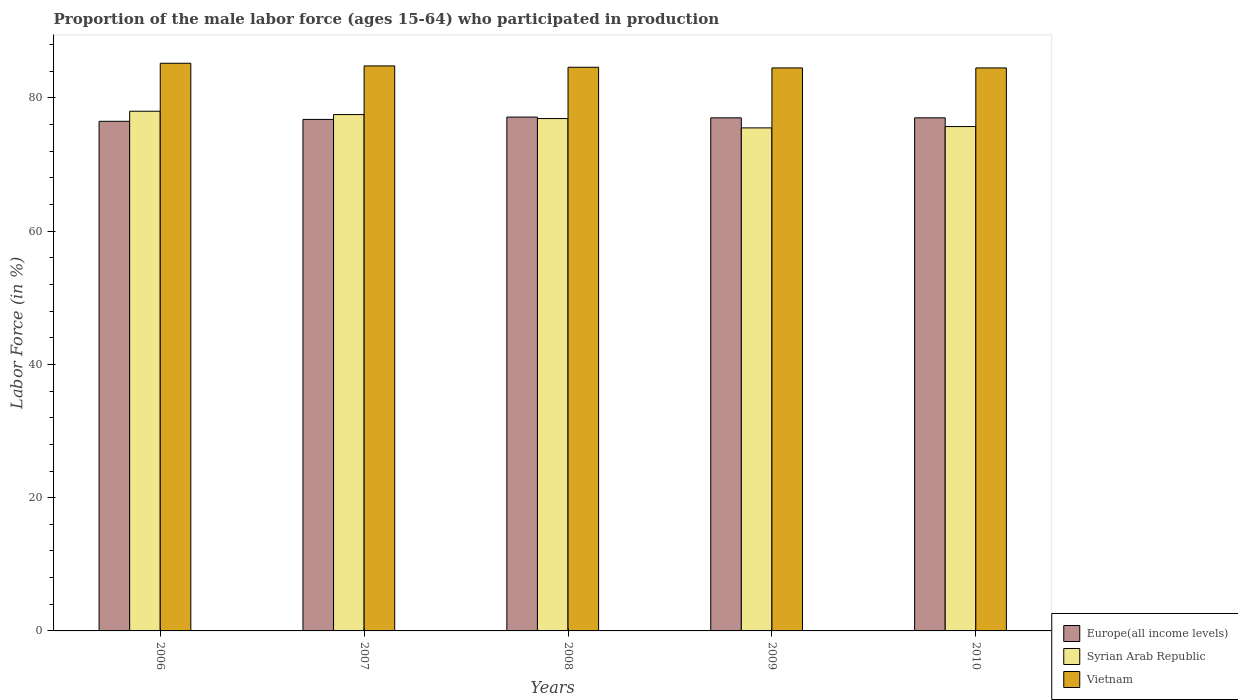How many different coloured bars are there?
Ensure brevity in your answer.  3. How many groups of bars are there?
Give a very brief answer. 5. Are the number of bars per tick equal to the number of legend labels?
Offer a terse response. Yes. Are the number of bars on each tick of the X-axis equal?
Your answer should be very brief. Yes. How many bars are there on the 4th tick from the left?
Give a very brief answer. 3. How many bars are there on the 1st tick from the right?
Provide a short and direct response. 3. What is the label of the 2nd group of bars from the left?
Keep it short and to the point. 2007. In how many cases, is the number of bars for a given year not equal to the number of legend labels?
Keep it short and to the point. 0. What is the proportion of the male labor force who participated in production in Europe(all income levels) in 2007?
Ensure brevity in your answer.  76.77. Across all years, what is the maximum proportion of the male labor force who participated in production in Syrian Arab Republic?
Make the answer very short. 78. Across all years, what is the minimum proportion of the male labor force who participated in production in Europe(all income levels)?
Your answer should be compact. 76.49. In which year was the proportion of the male labor force who participated in production in Syrian Arab Republic minimum?
Your response must be concise. 2009. What is the total proportion of the male labor force who participated in production in Vietnam in the graph?
Offer a very short reply. 423.6. What is the difference between the proportion of the male labor force who participated in production in Europe(all income levels) in 2006 and that in 2009?
Offer a terse response. -0.52. What is the difference between the proportion of the male labor force who participated in production in Europe(all income levels) in 2010 and the proportion of the male labor force who participated in production in Vietnam in 2009?
Provide a short and direct response. -7.49. What is the average proportion of the male labor force who participated in production in Vietnam per year?
Offer a terse response. 84.72. What is the ratio of the proportion of the male labor force who participated in production in Vietnam in 2008 to that in 2010?
Offer a terse response. 1. Is the proportion of the male labor force who participated in production in Syrian Arab Republic in 2008 less than that in 2009?
Keep it short and to the point. No. Is the difference between the proportion of the male labor force who participated in production in Vietnam in 2009 and 2010 greater than the difference between the proportion of the male labor force who participated in production in Syrian Arab Republic in 2009 and 2010?
Your answer should be very brief. Yes. What is the difference between the highest and the second highest proportion of the male labor force who participated in production in Vietnam?
Your answer should be compact. 0.4. What is the difference between the highest and the lowest proportion of the male labor force who participated in production in Syrian Arab Republic?
Your response must be concise. 2.5. What does the 3rd bar from the left in 2007 represents?
Ensure brevity in your answer.  Vietnam. What does the 3rd bar from the right in 2009 represents?
Keep it short and to the point. Europe(all income levels). Is it the case that in every year, the sum of the proportion of the male labor force who participated in production in Europe(all income levels) and proportion of the male labor force who participated in production in Vietnam is greater than the proportion of the male labor force who participated in production in Syrian Arab Republic?
Ensure brevity in your answer.  Yes. How many bars are there?
Your answer should be compact. 15. How many years are there in the graph?
Make the answer very short. 5. Are the values on the major ticks of Y-axis written in scientific E-notation?
Your answer should be very brief. No. Does the graph contain grids?
Ensure brevity in your answer.  No. What is the title of the graph?
Provide a short and direct response. Proportion of the male labor force (ages 15-64) who participated in production. Does "Lithuania" appear as one of the legend labels in the graph?
Your response must be concise. No. What is the label or title of the X-axis?
Your answer should be compact. Years. What is the label or title of the Y-axis?
Offer a terse response. Labor Force (in %). What is the Labor Force (in %) in Europe(all income levels) in 2006?
Offer a terse response. 76.49. What is the Labor Force (in %) in Vietnam in 2006?
Give a very brief answer. 85.2. What is the Labor Force (in %) of Europe(all income levels) in 2007?
Provide a succinct answer. 76.77. What is the Labor Force (in %) of Syrian Arab Republic in 2007?
Offer a very short reply. 77.5. What is the Labor Force (in %) in Vietnam in 2007?
Ensure brevity in your answer.  84.8. What is the Labor Force (in %) of Europe(all income levels) in 2008?
Your answer should be compact. 77.12. What is the Labor Force (in %) of Syrian Arab Republic in 2008?
Provide a succinct answer. 76.9. What is the Labor Force (in %) in Vietnam in 2008?
Offer a very short reply. 84.6. What is the Labor Force (in %) of Europe(all income levels) in 2009?
Ensure brevity in your answer.  77.01. What is the Labor Force (in %) in Syrian Arab Republic in 2009?
Offer a terse response. 75.5. What is the Labor Force (in %) in Vietnam in 2009?
Provide a short and direct response. 84.5. What is the Labor Force (in %) in Europe(all income levels) in 2010?
Make the answer very short. 77.01. What is the Labor Force (in %) in Syrian Arab Republic in 2010?
Make the answer very short. 75.7. What is the Labor Force (in %) in Vietnam in 2010?
Your answer should be very brief. 84.5. Across all years, what is the maximum Labor Force (in %) of Europe(all income levels)?
Your answer should be very brief. 77.12. Across all years, what is the maximum Labor Force (in %) of Vietnam?
Your response must be concise. 85.2. Across all years, what is the minimum Labor Force (in %) of Europe(all income levels)?
Make the answer very short. 76.49. Across all years, what is the minimum Labor Force (in %) in Syrian Arab Republic?
Your response must be concise. 75.5. Across all years, what is the minimum Labor Force (in %) of Vietnam?
Your answer should be compact. 84.5. What is the total Labor Force (in %) in Europe(all income levels) in the graph?
Your response must be concise. 384.4. What is the total Labor Force (in %) in Syrian Arab Republic in the graph?
Offer a very short reply. 383.6. What is the total Labor Force (in %) of Vietnam in the graph?
Provide a succinct answer. 423.6. What is the difference between the Labor Force (in %) of Europe(all income levels) in 2006 and that in 2007?
Offer a very short reply. -0.29. What is the difference between the Labor Force (in %) in Europe(all income levels) in 2006 and that in 2008?
Make the answer very short. -0.63. What is the difference between the Labor Force (in %) in Vietnam in 2006 and that in 2008?
Give a very brief answer. 0.6. What is the difference between the Labor Force (in %) in Europe(all income levels) in 2006 and that in 2009?
Your response must be concise. -0.52. What is the difference between the Labor Force (in %) in Syrian Arab Republic in 2006 and that in 2009?
Offer a very short reply. 2.5. What is the difference between the Labor Force (in %) in Vietnam in 2006 and that in 2009?
Your answer should be compact. 0.7. What is the difference between the Labor Force (in %) in Europe(all income levels) in 2006 and that in 2010?
Offer a terse response. -0.52. What is the difference between the Labor Force (in %) of Syrian Arab Republic in 2006 and that in 2010?
Your response must be concise. 2.3. What is the difference between the Labor Force (in %) in Vietnam in 2006 and that in 2010?
Offer a very short reply. 0.7. What is the difference between the Labor Force (in %) of Europe(all income levels) in 2007 and that in 2008?
Make the answer very short. -0.35. What is the difference between the Labor Force (in %) in Syrian Arab Republic in 2007 and that in 2008?
Give a very brief answer. 0.6. What is the difference between the Labor Force (in %) of Vietnam in 2007 and that in 2008?
Make the answer very short. 0.2. What is the difference between the Labor Force (in %) of Europe(all income levels) in 2007 and that in 2009?
Your answer should be very brief. -0.24. What is the difference between the Labor Force (in %) in Vietnam in 2007 and that in 2009?
Your answer should be compact. 0.3. What is the difference between the Labor Force (in %) of Europe(all income levels) in 2007 and that in 2010?
Make the answer very short. -0.24. What is the difference between the Labor Force (in %) in Syrian Arab Republic in 2007 and that in 2010?
Provide a short and direct response. 1.8. What is the difference between the Labor Force (in %) of Europe(all income levels) in 2008 and that in 2009?
Give a very brief answer. 0.11. What is the difference between the Labor Force (in %) of Europe(all income levels) in 2008 and that in 2010?
Provide a succinct answer. 0.11. What is the difference between the Labor Force (in %) in Europe(all income levels) in 2009 and that in 2010?
Ensure brevity in your answer.  -0. What is the difference between the Labor Force (in %) of Vietnam in 2009 and that in 2010?
Make the answer very short. 0. What is the difference between the Labor Force (in %) in Europe(all income levels) in 2006 and the Labor Force (in %) in Syrian Arab Republic in 2007?
Provide a succinct answer. -1.01. What is the difference between the Labor Force (in %) of Europe(all income levels) in 2006 and the Labor Force (in %) of Vietnam in 2007?
Provide a short and direct response. -8.31. What is the difference between the Labor Force (in %) of Syrian Arab Republic in 2006 and the Labor Force (in %) of Vietnam in 2007?
Keep it short and to the point. -6.8. What is the difference between the Labor Force (in %) of Europe(all income levels) in 2006 and the Labor Force (in %) of Syrian Arab Republic in 2008?
Give a very brief answer. -0.41. What is the difference between the Labor Force (in %) in Europe(all income levels) in 2006 and the Labor Force (in %) in Vietnam in 2008?
Provide a succinct answer. -8.11. What is the difference between the Labor Force (in %) of Syrian Arab Republic in 2006 and the Labor Force (in %) of Vietnam in 2008?
Offer a very short reply. -6.6. What is the difference between the Labor Force (in %) in Europe(all income levels) in 2006 and the Labor Force (in %) in Syrian Arab Republic in 2009?
Provide a short and direct response. 0.99. What is the difference between the Labor Force (in %) of Europe(all income levels) in 2006 and the Labor Force (in %) of Vietnam in 2009?
Your answer should be compact. -8.01. What is the difference between the Labor Force (in %) of Syrian Arab Republic in 2006 and the Labor Force (in %) of Vietnam in 2009?
Give a very brief answer. -6.5. What is the difference between the Labor Force (in %) of Europe(all income levels) in 2006 and the Labor Force (in %) of Syrian Arab Republic in 2010?
Keep it short and to the point. 0.79. What is the difference between the Labor Force (in %) in Europe(all income levels) in 2006 and the Labor Force (in %) in Vietnam in 2010?
Your answer should be compact. -8.01. What is the difference between the Labor Force (in %) of Syrian Arab Republic in 2006 and the Labor Force (in %) of Vietnam in 2010?
Your answer should be very brief. -6.5. What is the difference between the Labor Force (in %) of Europe(all income levels) in 2007 and the Labor Force (in %) of Syrian Arab Republic in 2008?
Offer a very short reply. -0.13. What is the difference between the Labor Force (in %) in Europe(all income levels) in 2007 and the Labor Force (in %) in Vietnam in 2008?
Your response must be concise. -7.83. What is the difference between the Labor Force (in %) in Syrian Arab Republic in 2007 and the Labor Force (in %) in Vietnam in 2008?
Provide a short and direct response. -7.1. What is the difference between the Labor Force (in %) in Europe(all income levels) in 2007 and the Labor Force (in %) in Syrian Arab Republic in 2009?
Keep it short and to the point. 1.27. What is the difference between the Labor Force (in %) of Europe(all income levels) in 2007 and the Labor Force (in %) of Vietnam in 2009?
Your answer should be compact. -7.73. What is the difference between the Labor Force (in %) of Europe(all income levels) in 2007 and the Labor Force (in %) of Syrian Arab Republic in 2010?
Offer a terse response. 1.07. What is the difference between the Labor Force (in %) in Europe(all income levels) in 2007 and the Labor Force (in %) in Vietnam in 2010?
Your response must be concise. -7.73. What is the difference between the Labor Force (in %) in Syrian Arab Republic in 2007 and the Labor Force (in %) in Vietnam in 2010?
Offer a very short reply. -7. What is the difference between the Labor Force (in %) in Europe(all income levels) in 2008 and the Labor Force (in %) in Syrian Arab Republic in 2009?
Your response must be concise. 1.62. What is the difference between the Labor Force (in %) of Europe(all income levels) in 2008 and the Labor Force (in %) of Vietnam in 2009?
Your response must be concise. -7.38. What is the difference between the Labor Force (in %) of Syrian Arab Republic in 2008 and the Labor Force (in %) of Vietnam in 2009?
Keep it short and to the point. -7.6. What is the difference between the Labor Force (in %) of Europe(all income levels) in 2008 and the Labor Force (in %) of Syrian Arab Republic in 2010?
Provide a short and direct response. 1.42. What is the difference between the Labor Force (in %) in Europe(all income levels) in 2008 and the Labor Force (in %) in Vietnam in 2010?
Your answer should be compact. -7.38. What is the difference between the Labor Force (in %) of Europe(all income levels) in 2009 and the Labor Force (in %) of Syrian Arab Republic in 2010?
Your answer should be very brief. 1.31. What is the difference between the Labor Force (in %) of Europe(all income levels) in 2009 and the Labor Force (in %) of Vietnam in 2010?
Your response must be concise. -7.49. What is the average Labor Force (in %) in Europe(all income levels) per year?
Your answer should be compact. 76.88. What is the average Labor Force (in %) in Syrian Arab Republic per year?
Your answer should be very brief. 76.72. What is the average Labor Force (in %) of Vietnam per year?
Make the answer very short. 84.72. In the year 2006, what is the difference between the Labor Force (in %) in Europe(all income levels) and Labor Force (in %) in Syrian Arab Republic?
Ensure brevity in your answer.  -1.51. In the year 2006, what is the difference between the Labor Force (in %) in Europe(all income levels) and Labor Force (in %) in Vietnam?
Your answer should be very brief. -8.71. In the year 2007, what is the difference between the Labor Force (in %) in Europe(all income levels) and Labor Force (in %) in Syrian Arab Republic?
Provide a short and direct response. -0.73. In the year 2007, what is the difference between the Labor Force (in %) of Europe(all income levels) and Labor Force (in %) of Vietnam?
Make the answer very short. -8.03. In the year 2007, what is the difference between the Labor Force (in %) in Syrian Arab Republic and Labor Force (in %) in Vietnam?
Give a very brief answer. -7.3. In the year 2008, what is the difference between the Labor Force (in %) in Europe(all income levels) and Labor Force (in %) in Syrian Arab Republic?
Make the answer very short. 0.22. In the year 2008, what is the difference between the Labor Force (in %) in Europe(all income levels) and Labor Force (in %) in Vietnam?
Ensure brevity in your answer.  -7.48. In the year 2009, what is the difference between the Labor Force (in %) in Europe(all income levels) and Labor Force (in %) in Syrian Arab Republic?
Your answer should be very brief. 1.51. In the year 2009, what is the difference between the Labor Force (in %) of Europe(all income levels) and Labor Force (in %) of Vietnam?
Offer a very short reply. -7.49. In the year 2009, what is the difference between the Labor Force (in %) of Syrian Arab Republic and Labor Force (in %) of Vietnam?
Your answer should be compact. -9. In the year 2010, what is the difference between the Labor Force (in %) in Europe(all income levels) and Labor Force (in %) in Syrian Arab Republic?
Your answer should be compact. 1.31. In the year 2010, what is the difference between the Labor Force (in %) of Europe(all income levels) and Labor Force (in %) of Vietnam?
Make the answer very short. -7.49. In the year 2010, what is the difference between the Labor Force (in %) of Syrian Arab Republic and Labor Force (in %) of Vietnam?
Give a very brief answer. -8.8. What is the ratio of the Labor Force (in %) of Europe(all income levels) in 2006 to that in 2007?
Make the answer very short. 1. What is the ratio of the Labor Force (in %) in Vietnam in 2006 to that in 2007?
Offer a very short reply. 1. What is the ratio of the Labor Force (in %) in Europe(all income levels) in 2006 to that in 2008?
Offer a terse response. 0.99. What is the ratio of the Labor Force (in %) of Syrian Arab Republic in 2006 to that in 2008?
Ensure brevity in your answer.  1.01. What is the ratio of the Labor Force (in %) of Vietnam in 2006 to that in 2008?
Offer a very short reply. 1.01. What is the ratio of the Labor Force (in %) in Syrian Arab Republic in 2006 to that in 2009?
Make the answer very short. 1.03. What is the ratio of the Labor Force (in %) of Vietnam in 2006 to that in 2009?
Give a very brief answer. 1.01. What is the ratio of the Labor Force (in %) of Europe(all income levels) in 2006 to that in 2010?
Your answer should be compact. 0.99. What is the ratio of the Labor Force (in %) of Syrian Arab Republic in 2006 to that in 2010?
Your answer should be very brief. 1.03. What is the ratio of the Labor Force (in %) of Vietnam in 2006 to that in 2010?
Ensure brevity in your answer.  1.01. What is the ratio of the Labor Force (in %) in Syrian Arab Republic in 2007 to that in 2008?
Make the answer very short. 1.01. What is the ratio of the Labor Force (in %) in Europe(all income levels) in 2007 to that in 2009?
Give a very brief answer. 1. What is the ratio of the Labor Force (in %) of Syrian Arab Republic in 2007 to that in 2009?
Make the answer very short. 1.03. What is the ratio of the Labor Force (in %) in Vietnam in 2007 to that in 2009?
Keep it short and to the point. 1. What is the ratio of the Labor Force (in %) in Europe(all income levels) in 2007 to that in 2010?
Ensure brevity in your answer.  1. What is the ratio of the Labor Force (in %) of Syrian Arab Republic in 2007 to that in 2010?
Ensure brevity in your answer.  1.02. What is the ratio of the Labor Force (in %) of Europe(all income levels) in 2008 to that in 2009?
Ensure brevity in your answer.  1. What is the ratio of the Labor Force (in %) of Syrian Arab Republic in 2008 to that in 2009?
Offer a terse response. 1.02. What is the ratio of the Labor Force (in %) of Vietnam in 2008 to that in 2009?
Keep it short and to the point. 1. What is the ratio of the Labor Force (in %) in Syrian Arab Republic in 2008 to that in 2010?
Make the answer very short. 1.02. What is the ratio of the Labor Force (in %) of Europe(all income levels) in 2009 to that in 2010?
Give a very brief answer. 1. What is the ratio of the Labor Force (in %) in Vietnam in 2009 to that in 2010?
Your answer should be very brief. 1. What is the difference between the highest and the second highest Labor Force (in %) in Europe(all income levels)?
Make the answer very short. 0.11. What is the difference between the highest and the second highest Labor Force (in %) in Syrian Arab Republic?
Provide a short and direct response. 0.5. What is the difference between the highest and the second highest Labor Force (in %) in Vietnam?
Your answer should be very brief. 0.4. What is the difference between the highest and the lowest Labor Force (in %) of Europe(all income levels)?
Offer a very short reply. 0.63. What is the difference between the highest and the lowest Labor Force (in %) in Syrian Arab Republic?
Keep it short and to the point. 2.5. 